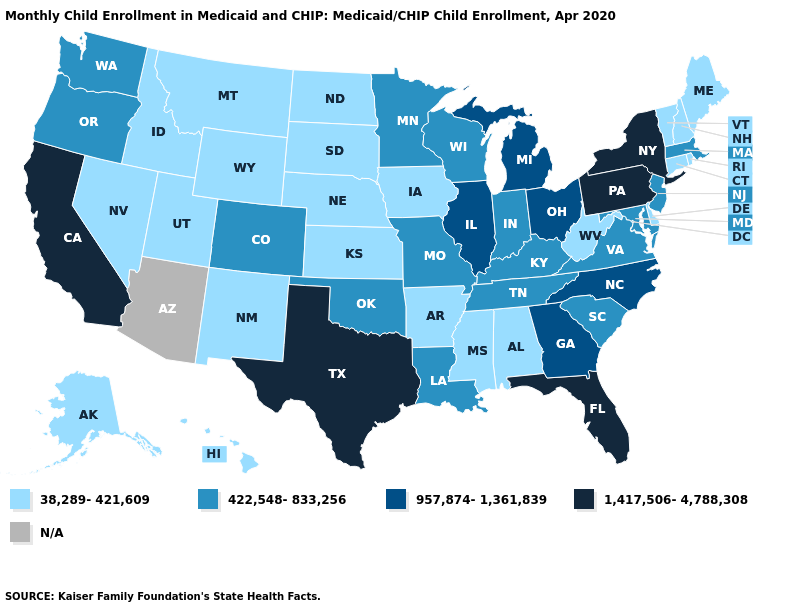Does the first symbol in the legend represent the smallest category?
Answer briefly. Yes. What is the lowest value in states that border Alabama?
Answer briefly. 38,289-421,609. Which states have the lowest value in the South?
Keep it brief. Alabama, Arkansas, Delaware, Mississippi, West Virginia. Name the states that have a value in the range 422,548-833,256?
Write a very short answer. Colorado, Indiana, Kentucky, Louisiana, Maryland, Massachusetts, Minnesota, Missouri, New Jersey, Oklahoma, Oregon, South Carolina, Tennessee, Virginia, Washington, Wisconsin. Name the states that have a value in the range 1,417,506-4,788,308?
Answer briefly. California, Florida, New York, Pennsylvania, Texas. Does the first symbol in the legend represent the smallest category?
Concise answer only. Yes. Does California have the highest value in the USA?
Be succinct. Yes. What is the value of Vermont?
Answer briefly. 38,289-421,609. What is the value of Vermont?
Answer briefly. 38,289-421,609. Does California have the lowest value in the USA?
Keep it brief. No. Which states hav the highest value in the Northeast?
Quick response, please. New York, Pennsylvania. Does the first symbol in the legend represent the smallest category?
Be succinct. Yes. What is the value of Pennsylvania?
Short answer required. 1,417,506-4,788,308. Which states have the lowest value in the USA?
Answer briefly. Alabama, Alaska, Arkansas, Connecticut, Delaware, Hawaii, Idaho, Iowa, Kansas, Maine, Mississippi, Montana, Nebraska, Nevada, New Hampshire, New Mexico, North Dakota, Rhode Island, South Dakota, Utah, Vermont, West Virginia, Wyoming. 